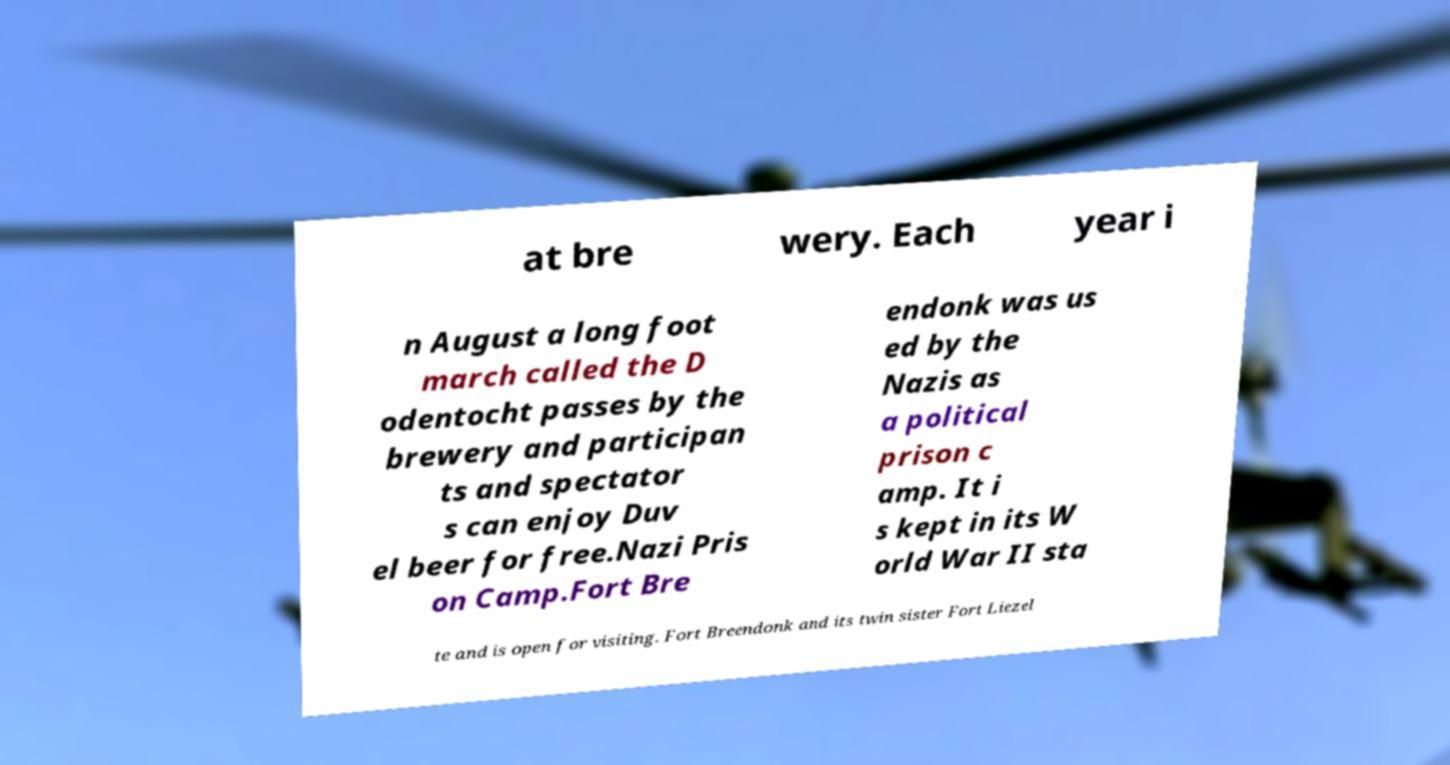Can you read and provide the text displayed in the image?This photo seems to have some interesting text. Can you extract and type it out for me? at bre wery. Each year i n August a long foot march called the D odentocht passes by the brewery and participan ts and spectator s can enjoy Duv el beer for free.Nazi Pris on Camp.Fort Bre endonk was us ed by the Nazis as a political prison c amp. It i s kept in its W orld War II sta te and is open for visiting. Fort Breendonk and its twin sister Fort Liezel 